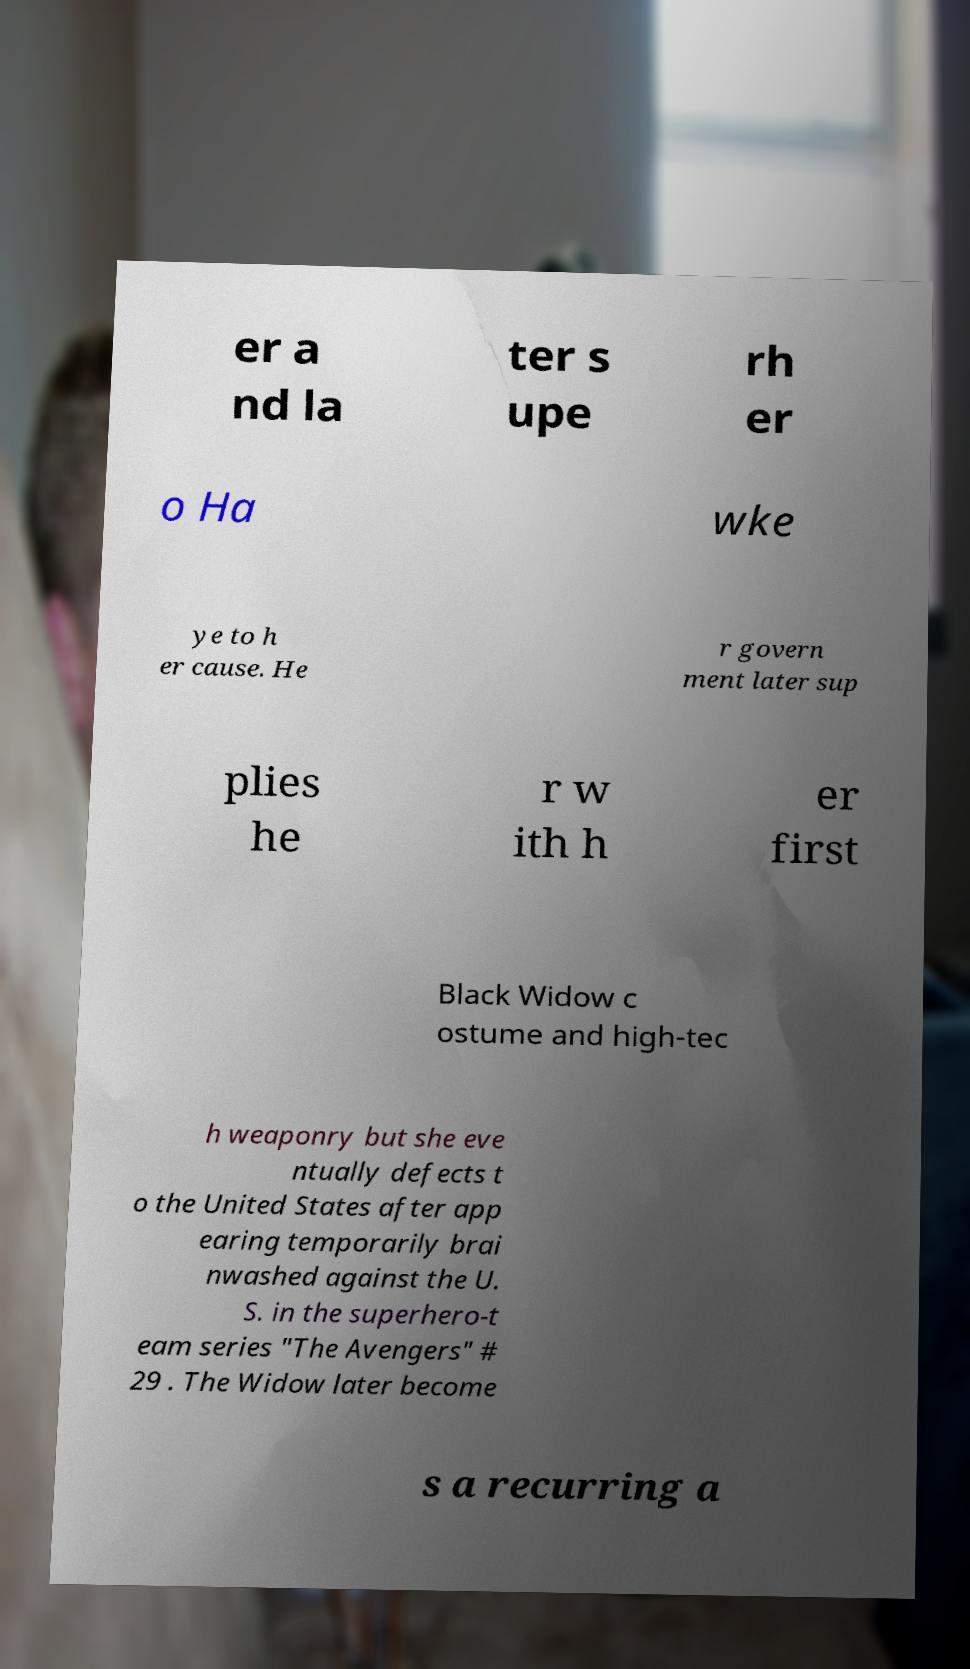Could you extract and type out the text from this image? er a nd la ter s upe rh er o Ha wke ye to h er cause. He r govern ment later sup plies he r w ith h er first Black Widow c ostume and high-tec h weaponry but she eve ntually defects t o the United States after app earing temporarily brai nwashed against the U. S. in the superhero-t eam series "The Avengers" # 29 . The Widow later become s a recurring a 